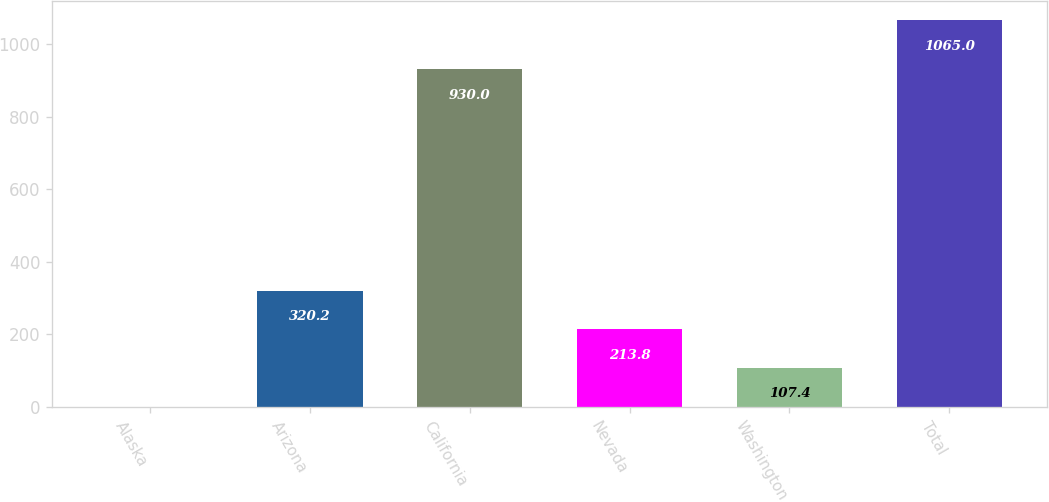Convert chart to OTSL. <chart><loc_0><loc_0><loc_500><loc_500><bar_chart><fcel>Alaska<fcel>Arizona<fcel>California<fcel>Nevada<fcel>Washington<fcel>Total<nl><fcel>1<fcel>320.2<fcel>930<fcel>213.8<fcel>107.4<fcel>1065<nl></chart> 